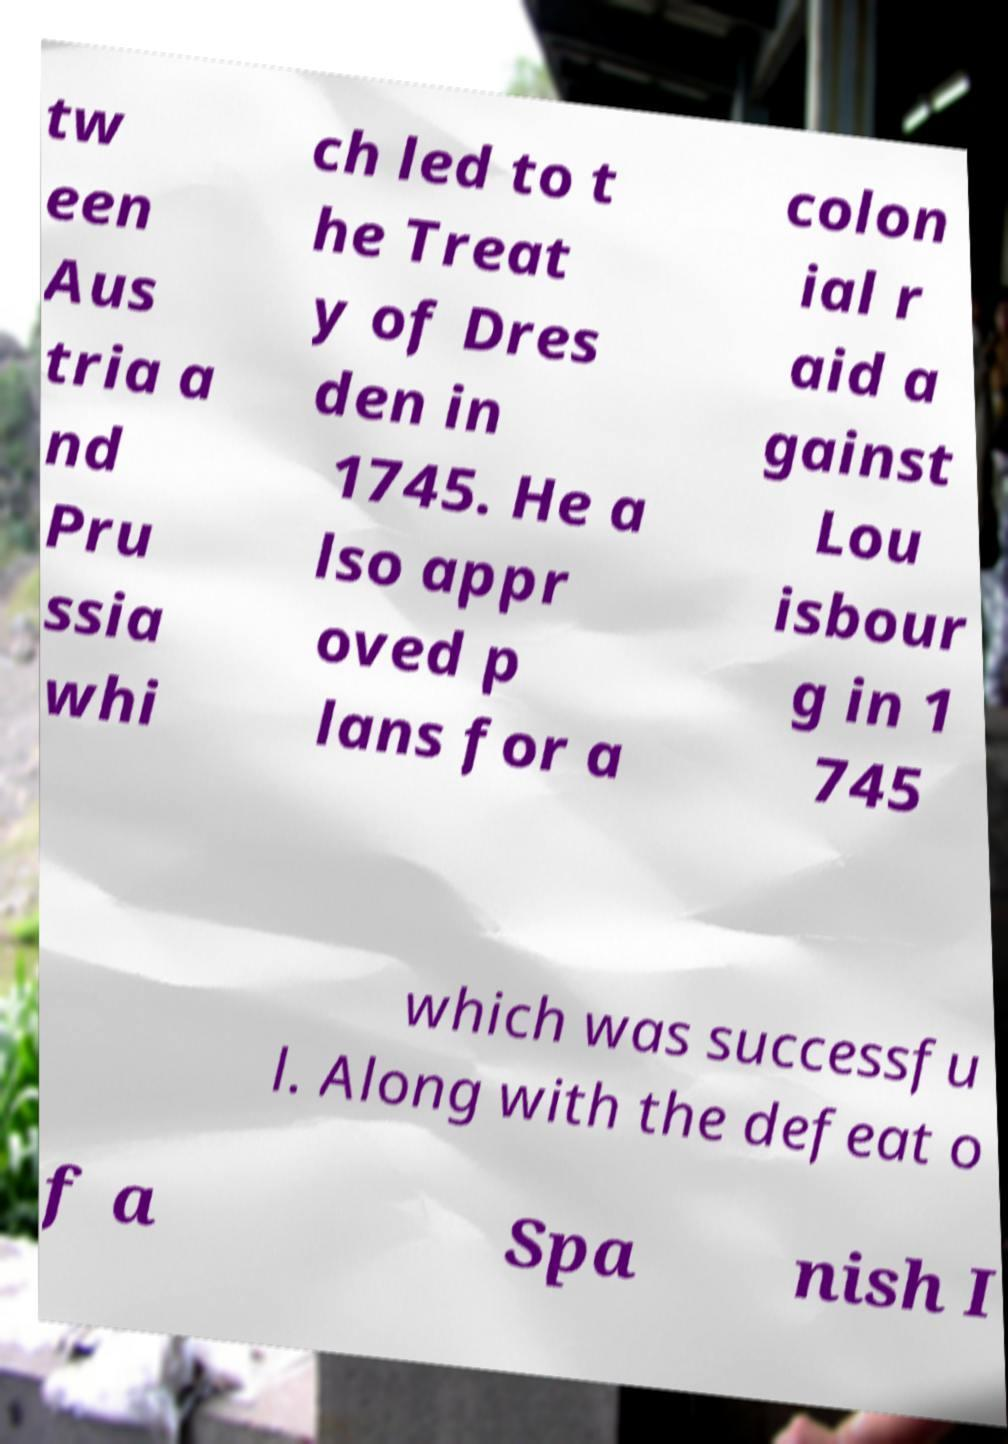Could you extract and type out the text from this image? tw een Aus tria a nd Pru ssia whi ch led to t he Treat y of Dres den in 1745. He a lso appr oved p lans for a colon ial r aid a gainst Lou isbour g in 1 745 which was successfu l. Along with the defeat o f a Spa nish I 